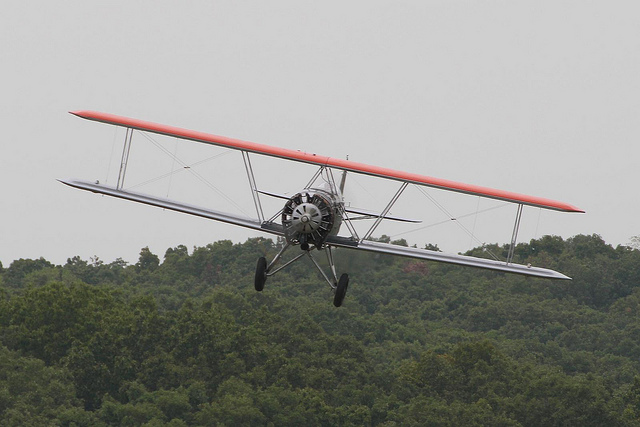What can you tell me about the technology advancements that this type of biplane represents? This biplane represents significant advancements in aviation technology at the time, such as the development of the radial engine for better reliability and performance. The structural design provided strength and rigidity, enabling the biplane to perform complex maneuvers. The two-wing configuration allowed for improved lift, which was essential before aerodynamic shaping of wings had evolved. It's a testament to the rapid progression of aircraft design in the early days of flight. 